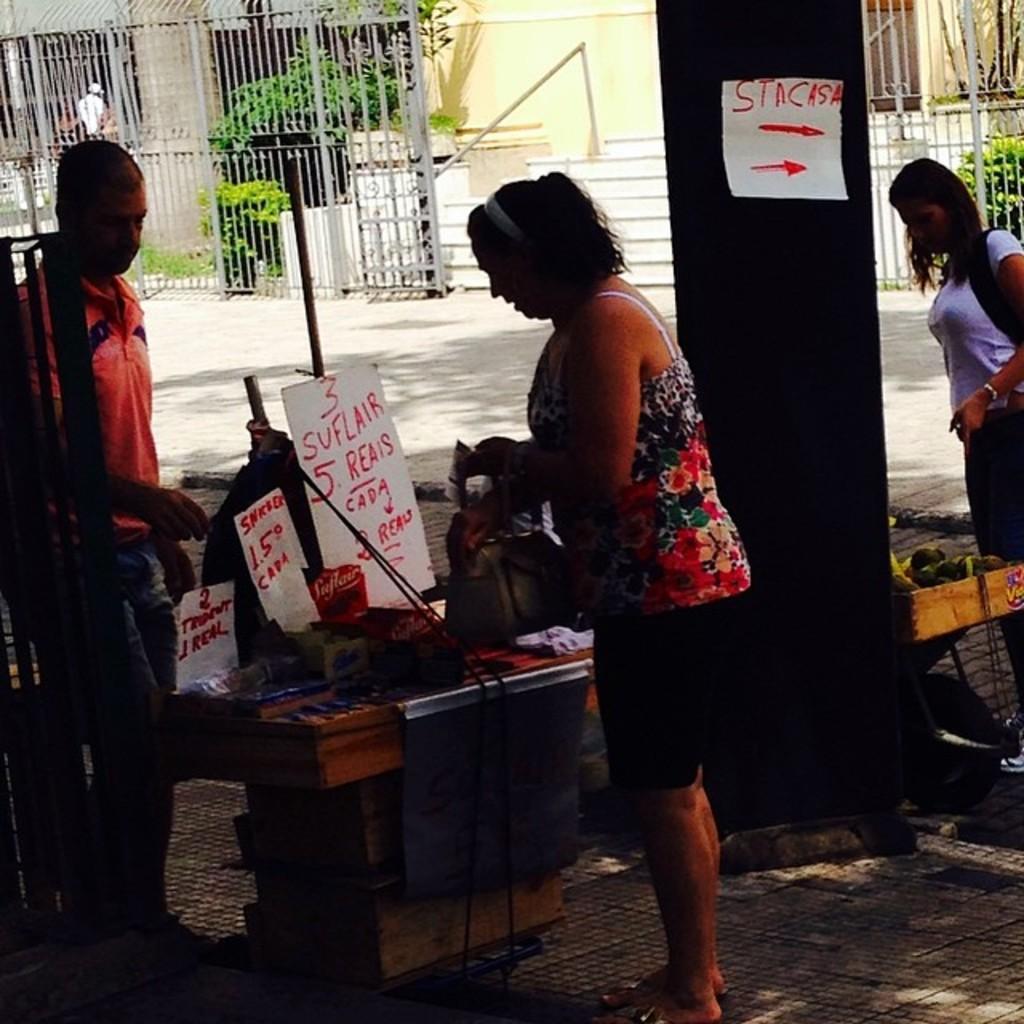Describe this image in one or two sentences. In this image we can see a women standing on the road and holding a handbag in her hands. This is the table where few things are placed on it. In the background of the image we can see a fence, building and trees. 